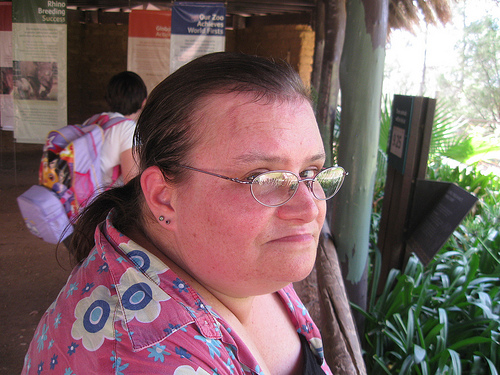<image>
Can you confirm if the women is on the eyeglass? No. The women is not positioned on the eyeglass. They may be near each other, but the women is not supported by or resting on top of the eyeglass. 